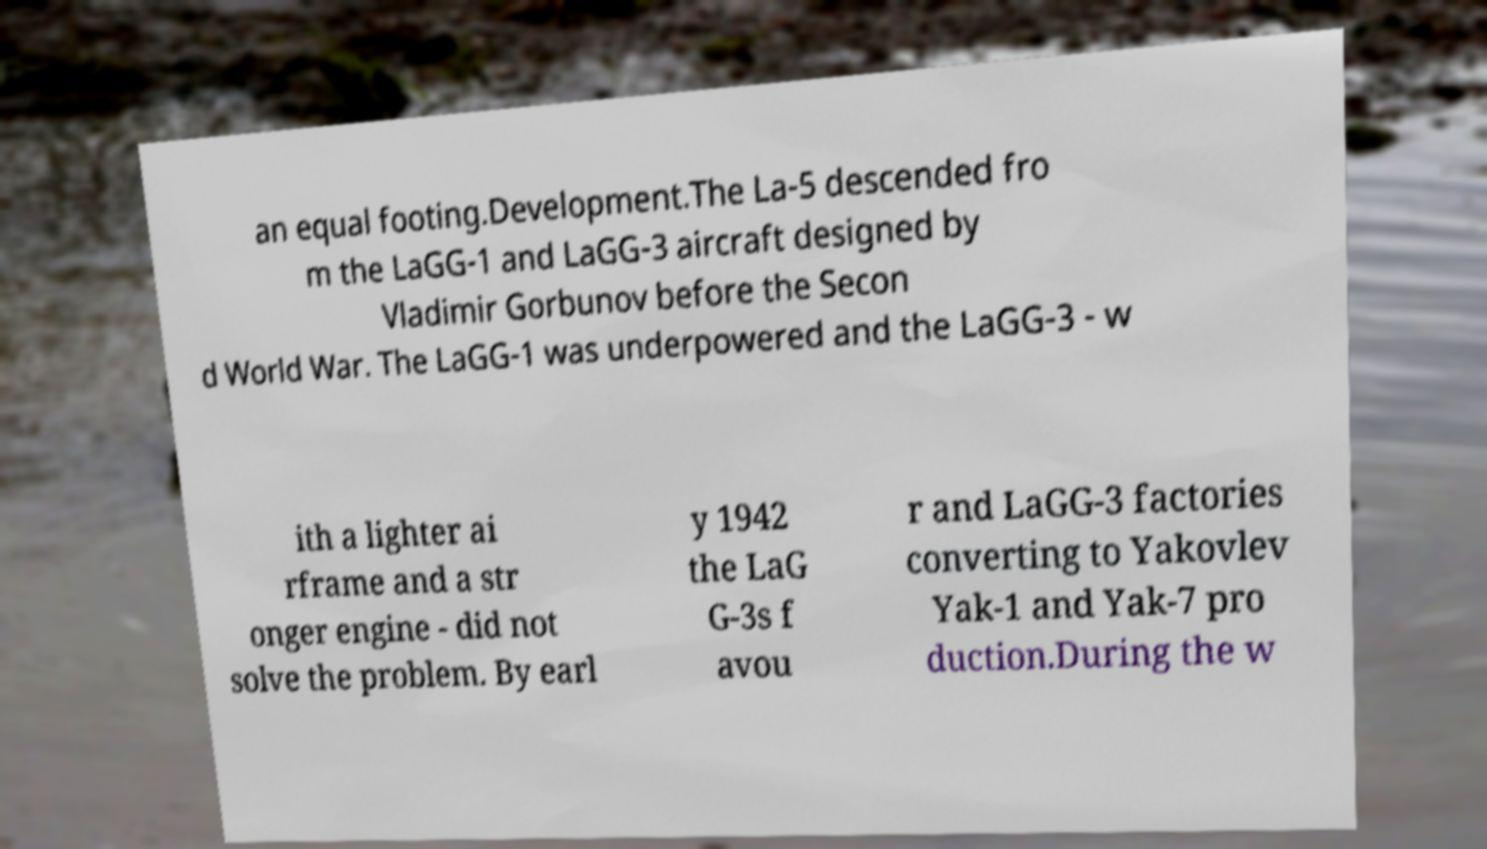I need the written content from this picture converted into text. Can you do that? an equal footing.Development.The La-5 descended fro m the LaGG-1 and LaGG-3 aircraft designed by Vladimir Gorbunov before the Secon d World War. The LaGG-1 was underpowered and the LaGG-3 - w ith a lighter ai rframe and a str onger engine - did not solve the problem. By earl y 1942 the LaG G-3s f avou r and LaGG-3 factories converting to Yakovlev Yak-1 and Yak-7 pro duction.During the w 